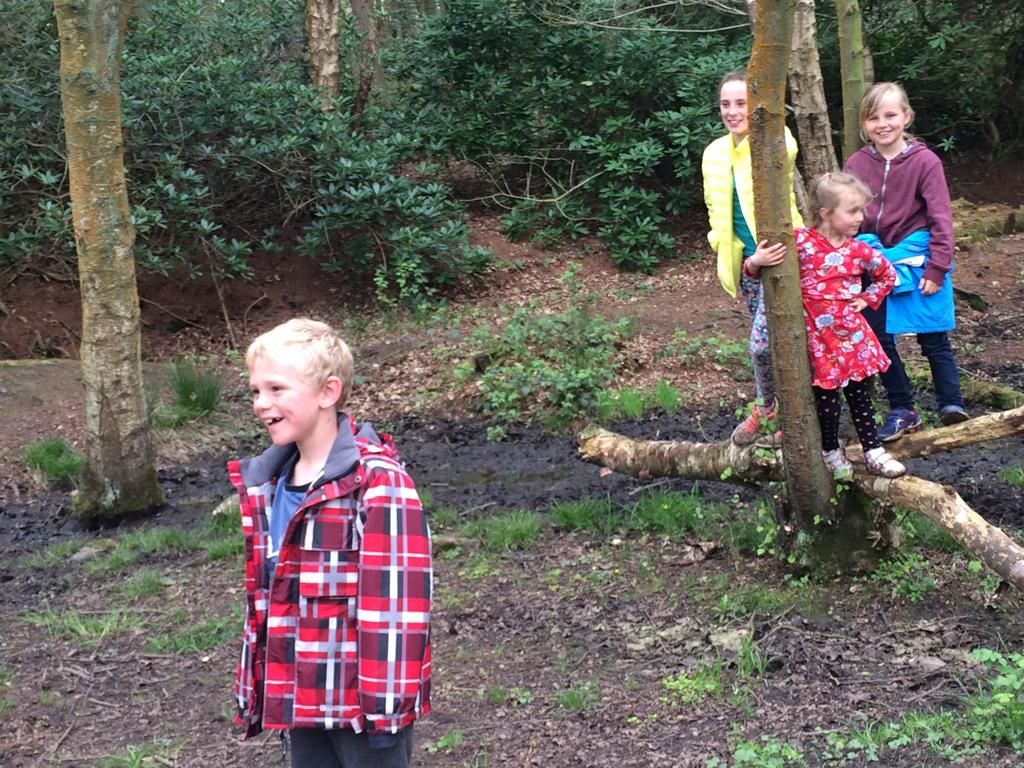What is the main subject of the image? There is a boy standing in the image. Can you describe the background of the image? There are three persons standing on the branch of a tree in the background of the image, and plants are visible. What type of vegetation is present in the image? Grass is present in the image. What type of reading material is the giraffe holding in the image? There is no giraffe present in the image, and therefore no reading material can be observed. What game are the people playing in the image? There is no game being played in the image; it features a boy standing and three persons on a tree branch. 